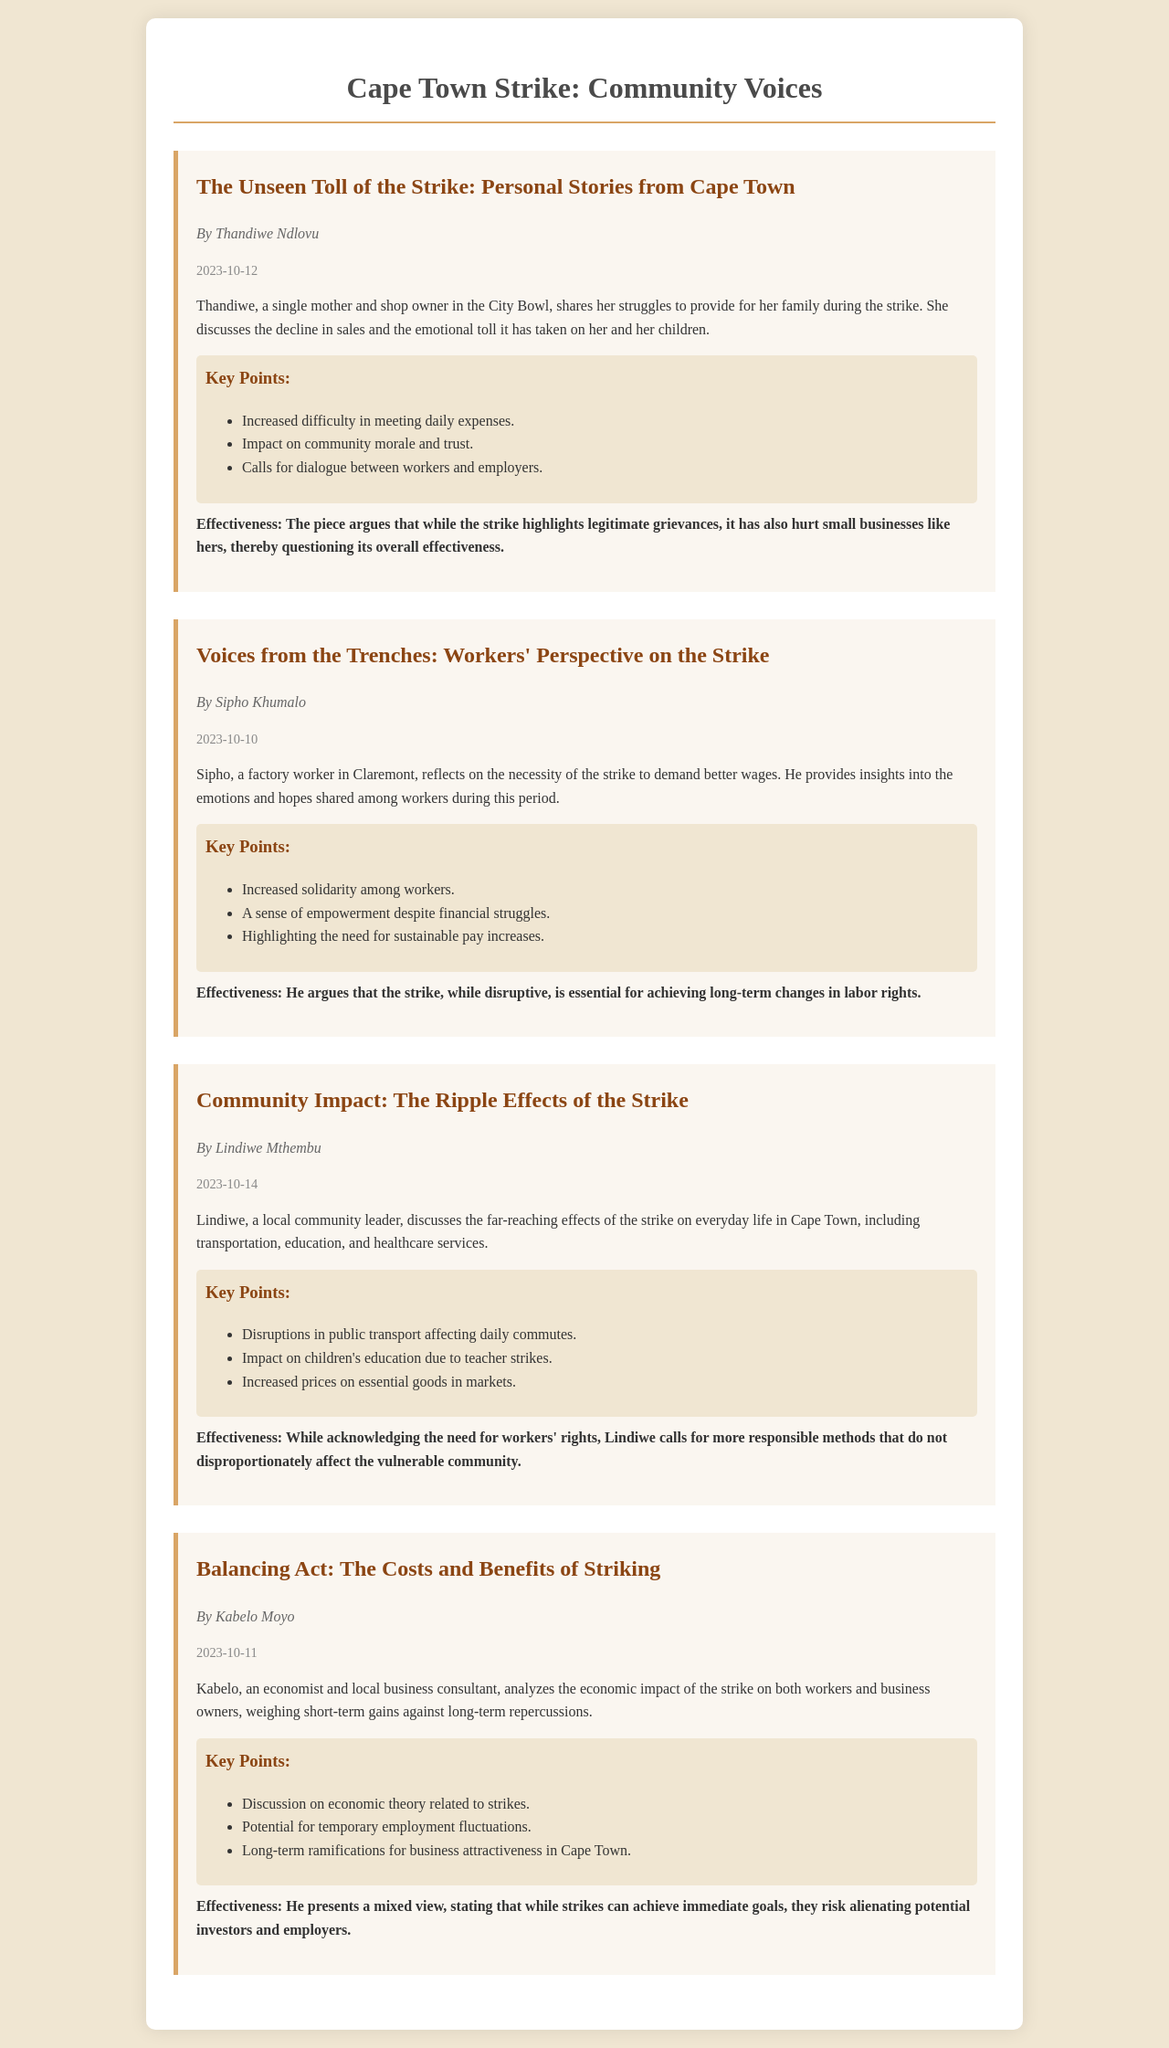What is the title of Thandiwe Ndlovu's opinion piece? The title is the heading of her section, which is clearly stated in the document.
Answer: The Unseen Toll of the Strike: Personal Stories from Cape Town Who authored the opinion piece discussing the workers' perspective? This information can be found under the author's name in the respective opinion piece section.
Answer: Sipho Khumalo What date was Lindiwe Mthembu's opinion piece published? The date can be found right below the author's name, indicating when the piece was made public.
Answer: 2023-10-14 What key point does Kabelo Moyo mention regarding economic theory? This is listed in the summary of key points under his opinion piece, which focuses on economic impacts.
Answer: Discussion on economic theory related to strikes What is the main concern raised by Thandiwe Ndlovu regarding the strike's impact? The concern is indicated in her summary about how the strike affects her business and family.
Answer: Difficulty in meeting daily expenses What does Sipho Khumalo say about the emotions shared among workers? This insight is part of Sipho's reflections on the feelings of his coworkers during the strike period.
Answer: Sense of empowerment despite financial struggles Which community services are discussed in relation to the strike's effects in Lindiwe Mthembu's piece? This information is summarized in the section that highlights the ripple effects on various sectors.
Answer: Transportation, education, and healthcare services What does Kabelo Moyo suggest about the potential effects on business attractiveness? This is derived from the effectiveness portion of his opinion, where he discusses long-term implications.
Answer: Long-term ramifications for business attractiveness in Cape Town 